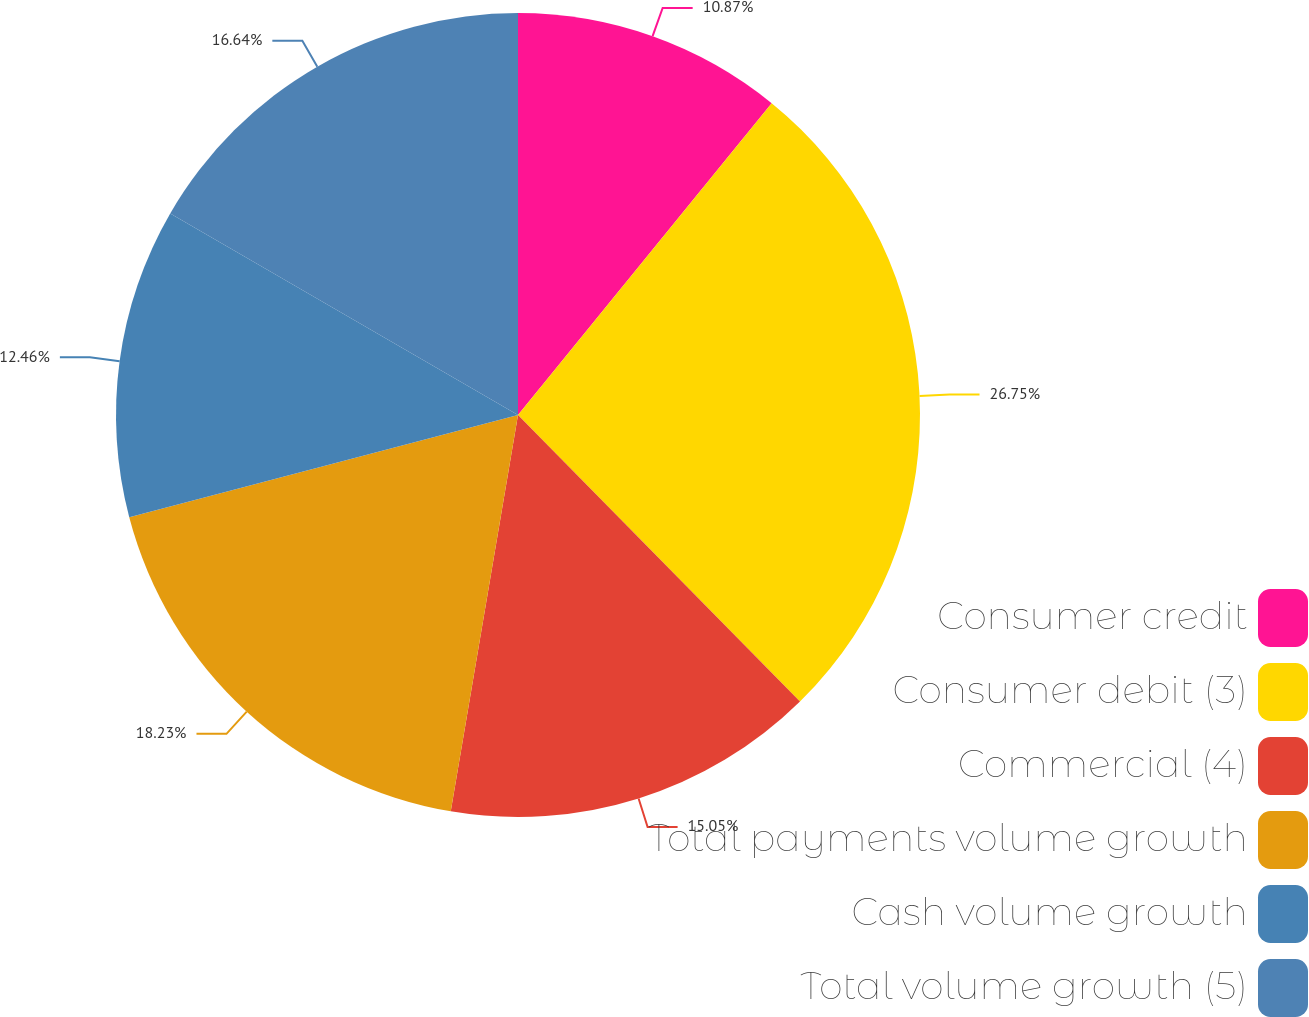Convert chart. <chart><loc_0><loc_0><loc_500><loc_500><pie_chart><fcel>Consumer credit<fcel>Consumer debit (3)<fcel>Commercial (4)<fcel>Total payments volume growth<fcel>Cash volume growth<fcel>Total volume growth (5)<nl><fcel>10.87%<fcel>26.76%<fcel>15.05%<fcel>18.23%<fcel>12.46%<fcel>16.64%<nl></chart> 